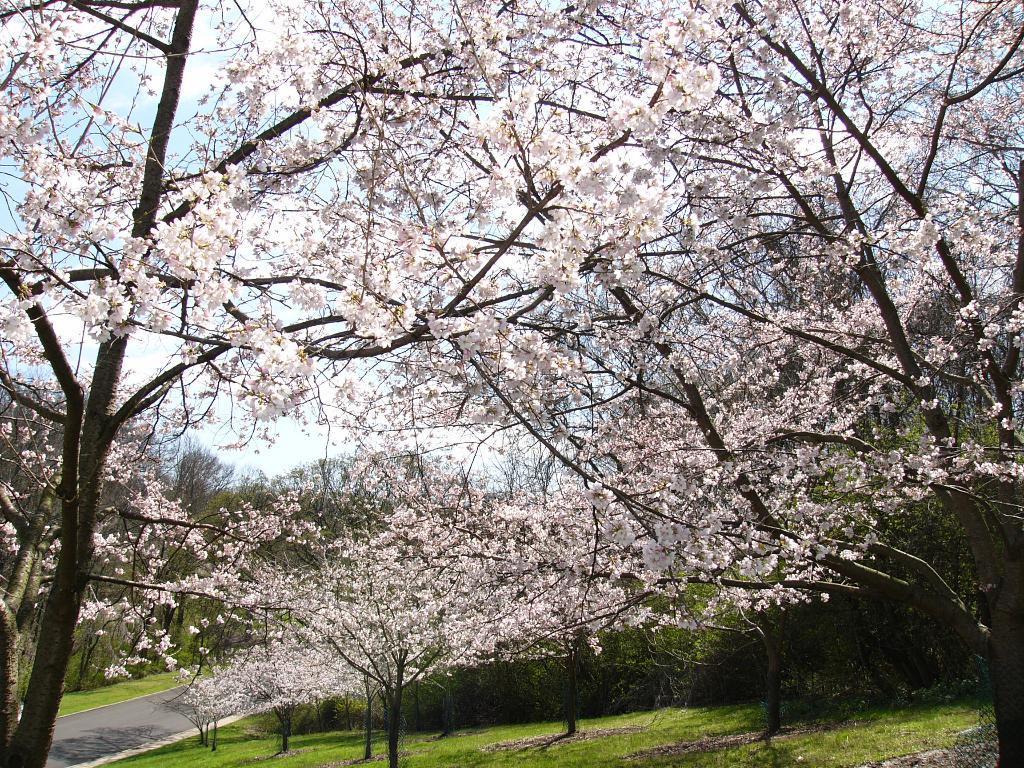Can you describe this image briefly? In the picture I can see trees which are having white color leaves. Here I can see the grass, road on the left side of the image and I can see the sky in the background. 